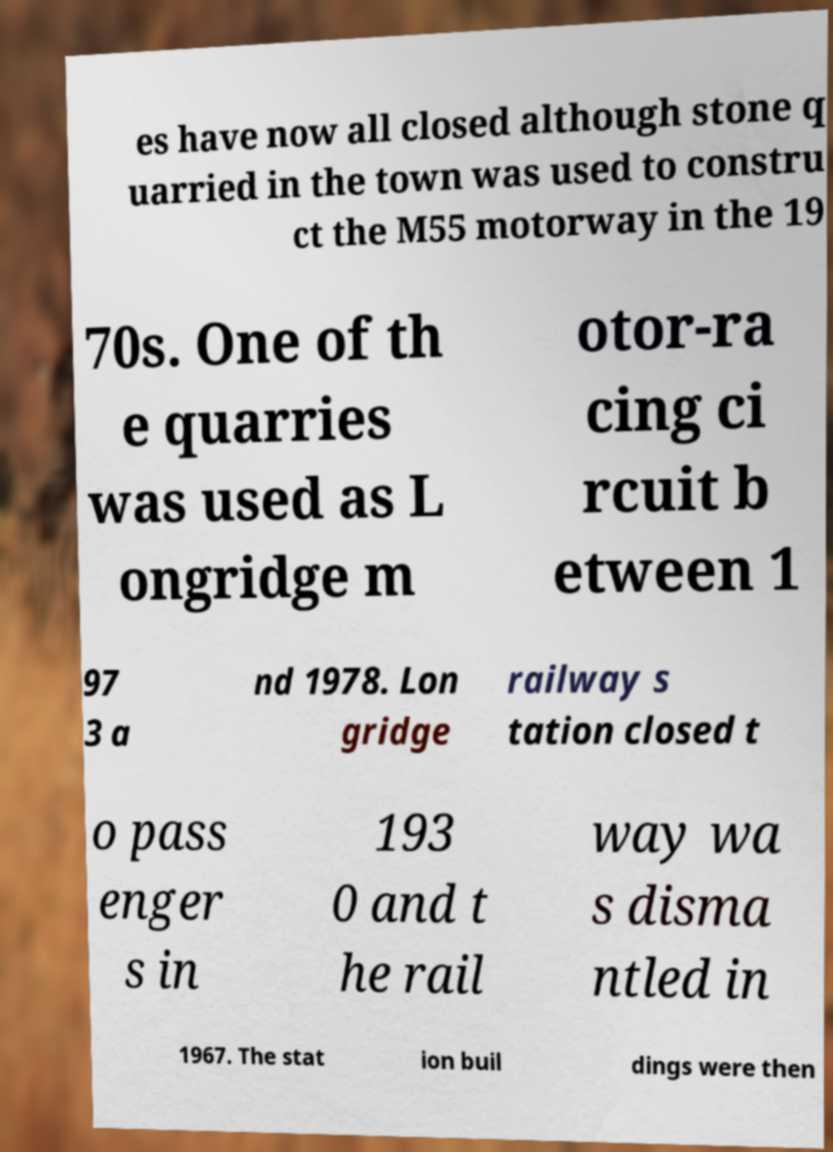Please read and relay the text visible in this image. What does it say? es have now all closed although stone q uarried in the town was used to constru ct the M55 motorway in the 19 70s. One of th e quarries was used as L ongridge m otor-ra cing ci rcuit b etween 1 97 3 a nd 1978. Lon gridge railway s tation closed t o pass enger s in 193 0 and t he rail way wa s disma ntled in 1967. The stat ion buil dings were then 